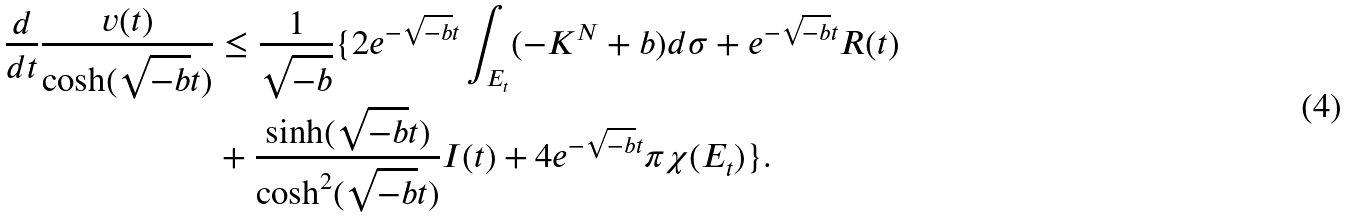Convert formula to latex. <formula><loc_0><loc_0><loc_500><loc_500>\frac { d } { d t } \frac { v ( t ) } { \cosh ( \sqrt { - b } t ) } & \leq \frac { 1 } { \sqrt { - b } } \{ 2 e ^ { - \sqrt { - b } t } \int _ { E _ { t } } ( - K ^ { N } + b ) d \sigma + e ^ { - \sqrt { - b } t } R ( t ) \\ & + \frac { \sinh ( \sqrt { - b } t ) } { \cosh ^ { 2 } ( \sqrt { - b } t ) } I ( t ) + 4 e ^ { - \sqrt { - b } t } \pi \chi ( E _ { t } ) \} .</formula> 